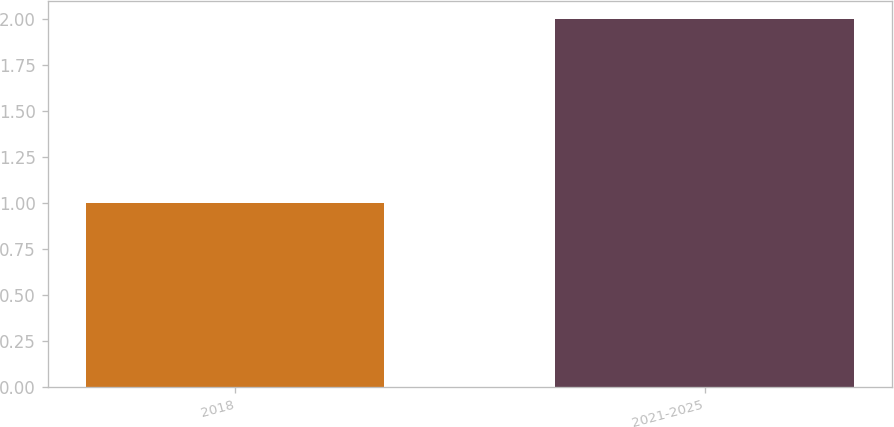Convert chart. <chart><loc_0><loc_0><loc_500><loc_500><bar_chart><fcel>2018<fcel>2021-2025<nl><fcel>1<fcel>2<nl></chart> 